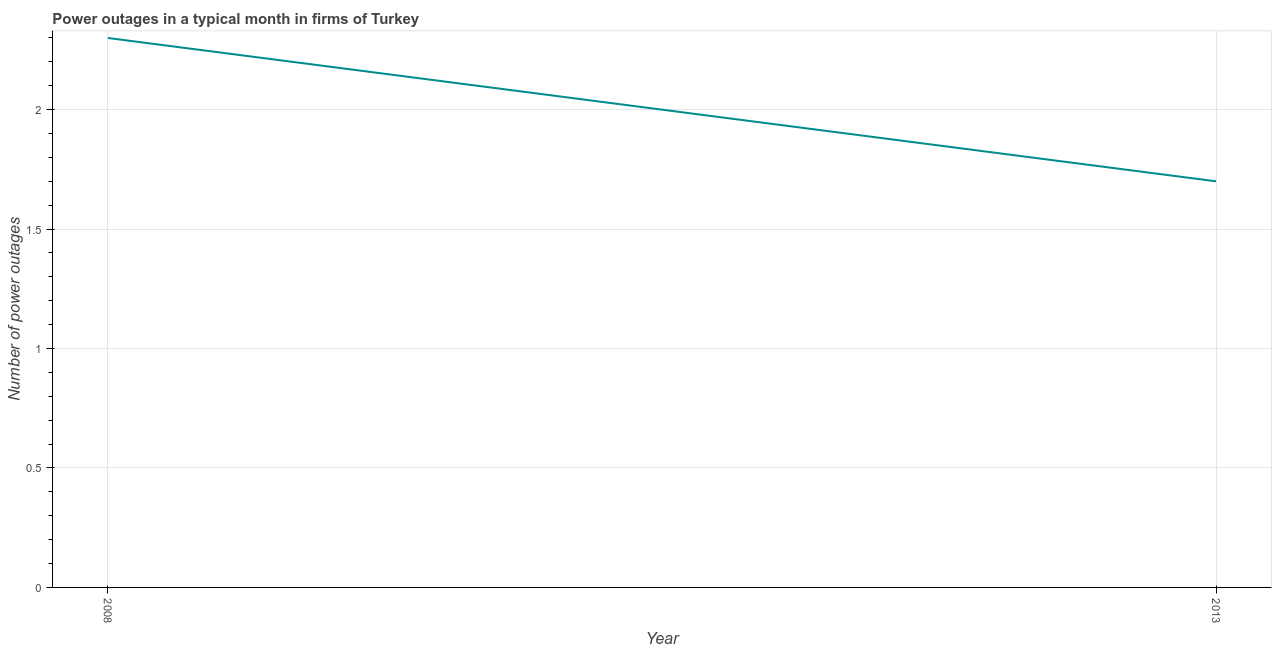Across all years, what is the maximum number of power outages?
Make the answer very short. 2.3. Across all years, what is the minimum number of power outages?
Your answer should be compact. 1.7. What is the difference between the number of power outages in 2008 and 2013?
Provide a succinct answer. 0.6. What is the median number of power outages?
Make the answer very short. 2. What is the ratio of the number of power outages in 2008 to that in 2013?
Your answer should be compact. 1.35. Is the number of power outages in 2008 less than that in 2013?
Give a very brief answer. No. Does the number of power outages monotonically increase over the years?
Give a very brief answer. No. Are the values on the major ticks of Y-axis written in scientific E-notation?
Ensure brevity in your answer.  No. Does the graph contain any zero values?
Ensure brevity in your answer.  No. What is the title of the graph?
Offer a very short reply. Power outages in a typical month in firms of Turkey. What is the label or title of the Y-axis?
Your response must be concise. Number of power outages. What is the Number of power outages in 2008?
Your answer should be compact. 2.3. What is the Number of power outages in 2013?
Keep it short and to the point. 1.7. What is the difference between the Number of power outages in 2008 and 2013?
Make the answer very short. 0.6. What is the ratio of the Number of power outages in 2008 to that in 2013?
Offer a terse response. 1.35. 